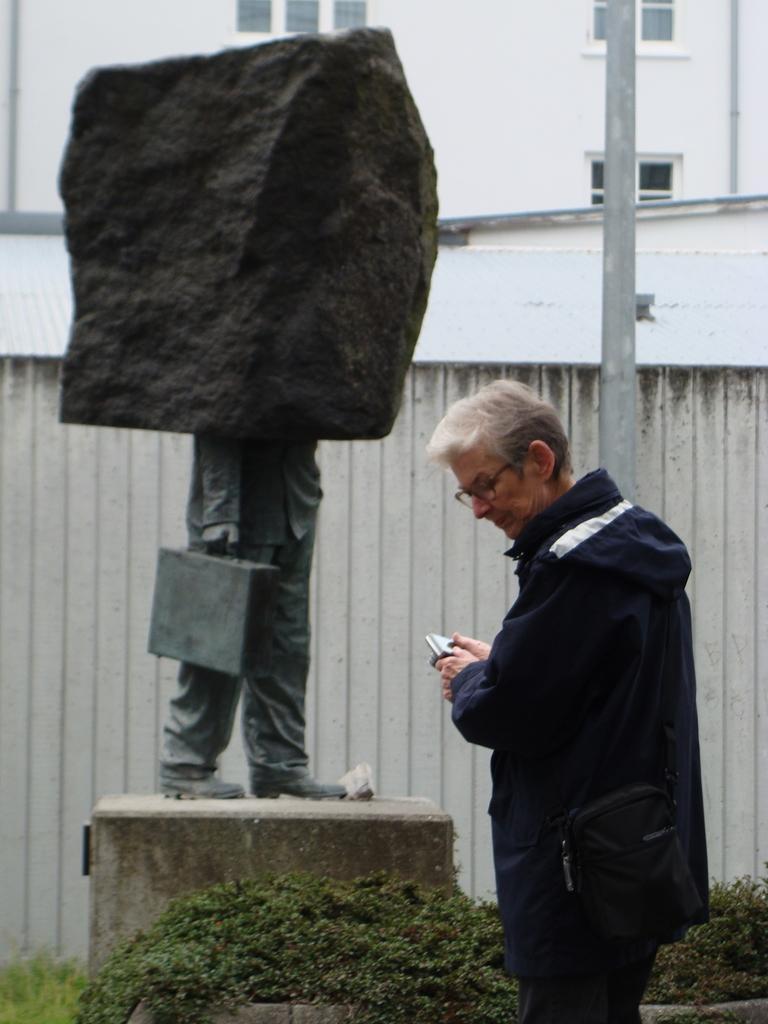Describe this image in one or two sentences. In this image we can see one building, one statue, two pipes attached to the building, one object near the statue, one pole near the wall, some plants, some grass on the ground, one man in suit standing and holding one object. 